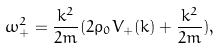Convert formula to latex. <formula><loc_0><loc_0><loc_500><loc_500>\omega _ { + } ^ { 2 } = \frac { k ^ { 2 } } { 2 m } ( 2 \rho _ { 0 } V _ { + } ( k ) + \frac { k ^ { 2 } } { 2 m } ) ,</formula> 